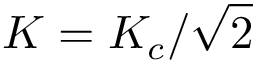Convert formula to latex. <formula><loc_0><loc_0><loc_500><loc_500>K = K _ { c } / \sqrt { 2 }</formula> 